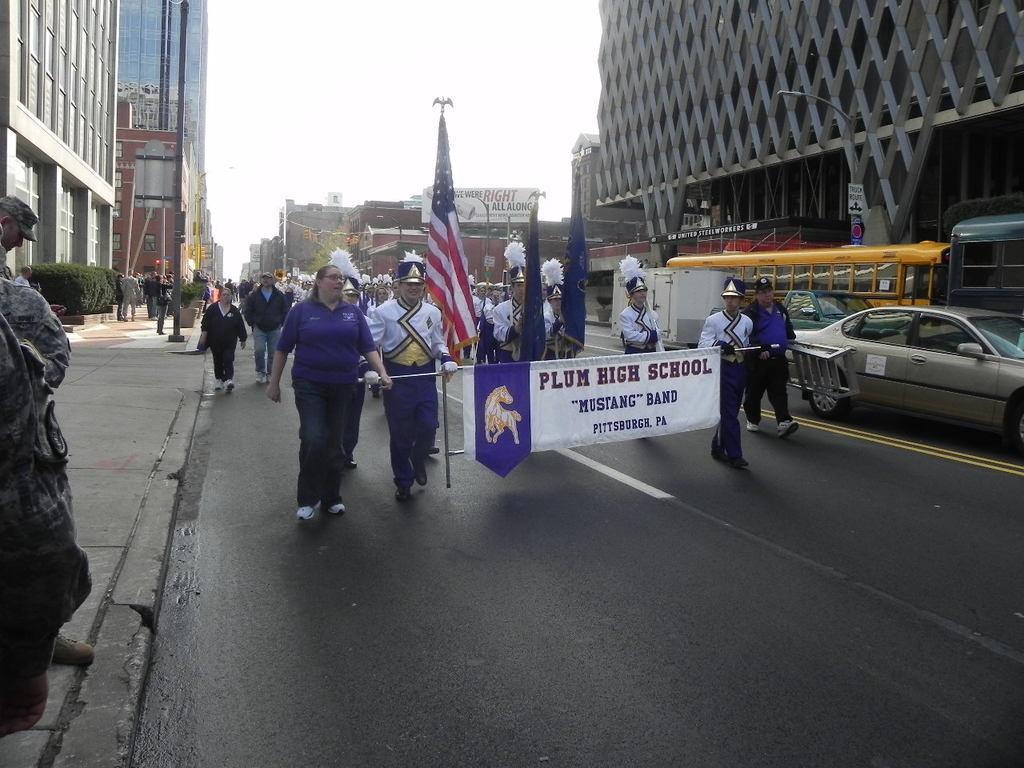Please provide a concise description of this image. In the picture I can see these people wearing white color dresses, hats and shoes are holding banners in their hands and walking on the road. Here we can see a few more people walking on the road, we can see flags, vehicles moving on the road, people walking on the sidewalk, we can see buildings on either side of the image and the sky in the background. 